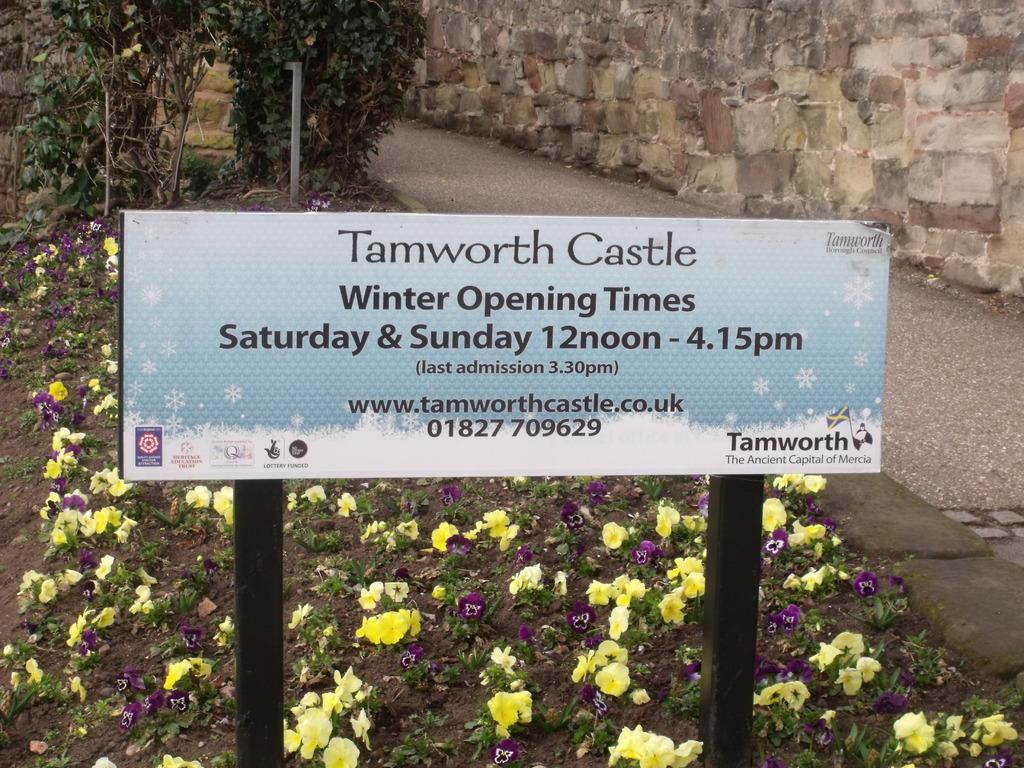What is written or displayed on the board in the image? There is a board with text in the image. What type of vegetation can be seen in the image? There are plants, trees, and flowers in the image. Is there a designated route or path in the image? Yes, there is a path on the right side of the image. What architectural feature is present in the image? There is a wall in the image. Can you see an airplane flying over the wall in the image? There is no airplane present in the image. How many times does the path twist in the image? The path does not twist in the image; it is a straight path. 